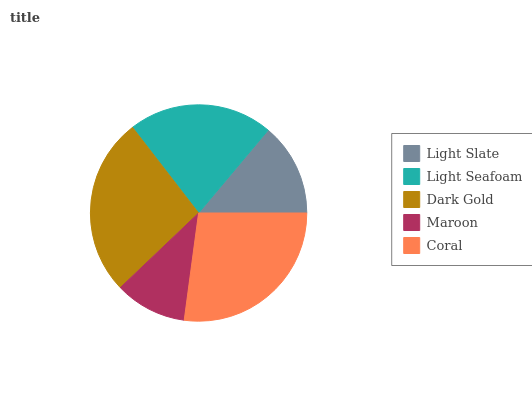Is Maroon the minimum?
Answer yes or no. Yes. Is Coral the maximum?
Answer yes or no. Yes. Is Light Seafoam the minimum?
Answer yes or no. No. Is Light Seafoam the maximum?
Answer yes or no. No. Is Light Seafoam greater than Light Slate?
Answer yes or no. Yes. Is Light Slate less than Light Seafoam?
Answer yes or no. Yes. Is Light Slate greater than Light Seafoam?
Answer yes or no. No. Is Light Seafoam less than Light Slate?
Answer yes or no. No. Is Light Seafoam the high median?
Answer yes or no. Yes. Is Light Seafoam the low median?
Answer yes or no. Yes. Is Light Slate the high median?
Answer yes or no. No. Is Light Slate the low median?
Answer yes or no. No. 